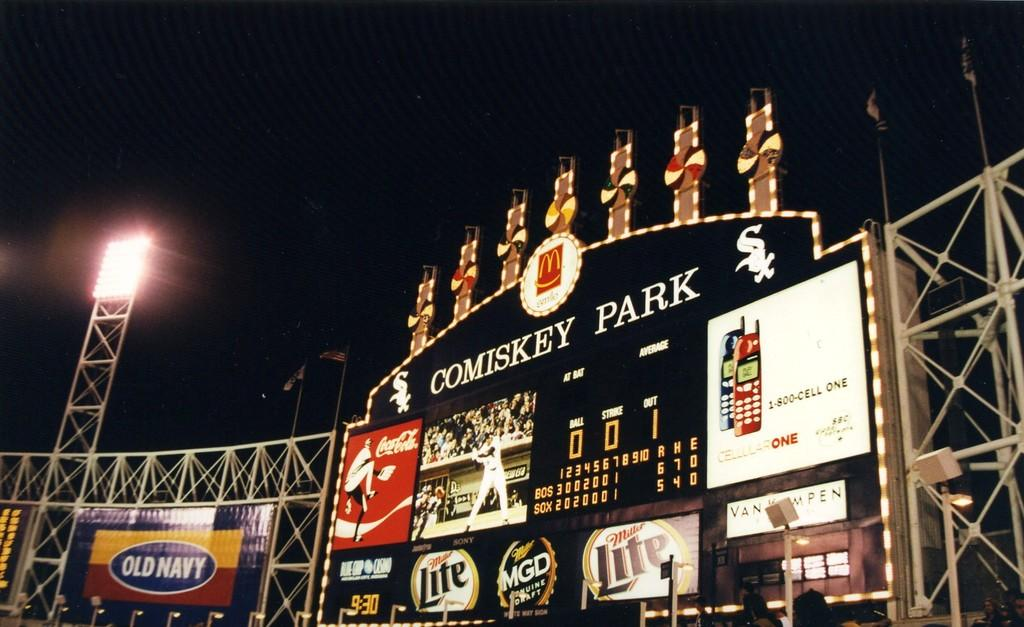Provide a one-sentence caption for the provided image. A baseball stadium at night with the lights on with large billboard saying Cominsky Park and with many advertisements being displayed. 